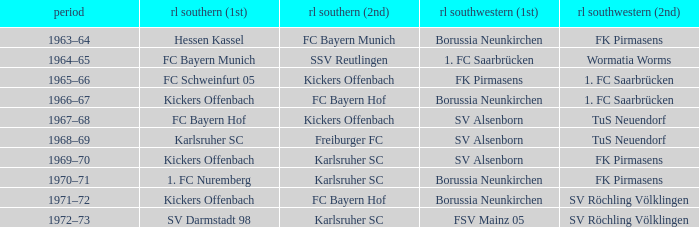Who was RL Süd (1st) when FK Pirmasens was RL Südwest (1st)? FC Schweinfurt 05. 